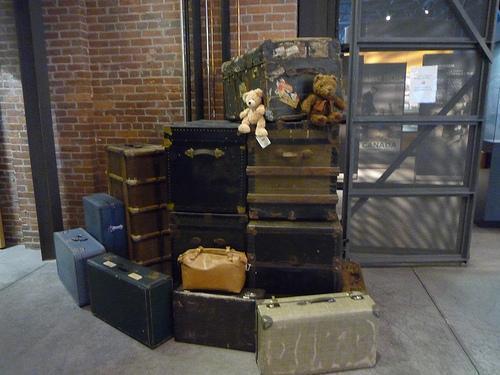How many bears are there?
Give a very brief answer. 2. 